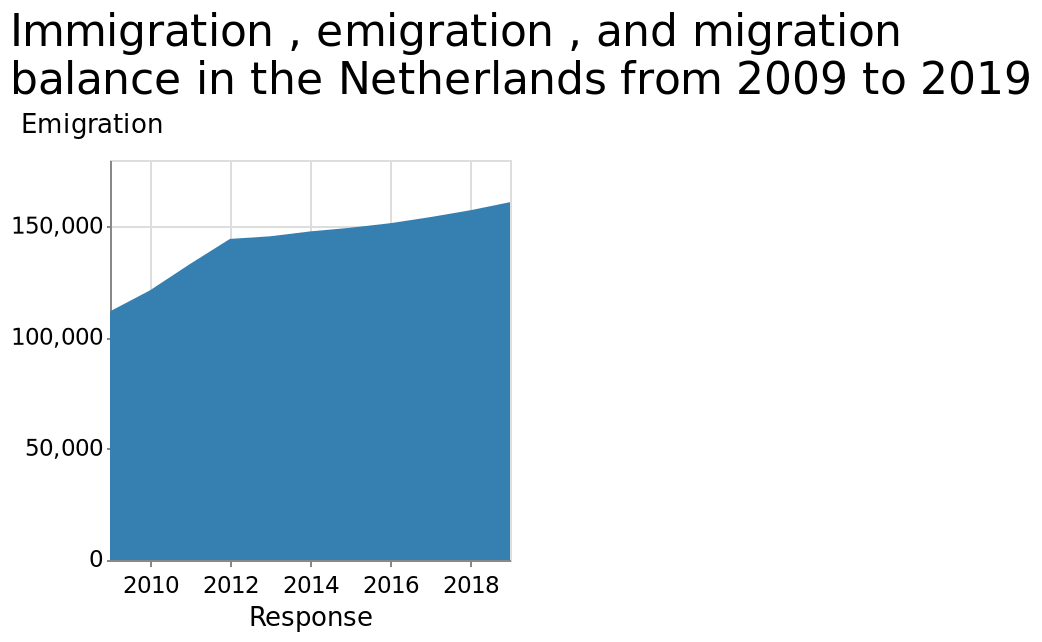<image>
What is the title of the area plot?  The title of the area plot is "Immigration, Emigration, and Migration Balance in the Netherlands from 2009 to 2019". What is measured on the x-axis of the area plot?  The x-axis of the area plot represents the response variable. What was the total balance between immigration, emigration, and migration in 2010? The total balance between immigration, emigration, and migration was just over 100,000 in 2010. please describe the details of the chart Here a is a area plot called Immigration , emigration , and migration balance in the Netherlands from 2009 to 2019. A linear scale from 0 to 150,000 can be seen on the y-axis, marked Emigration. Response is measured on the x-axis. What was the balance between immigration, emigration, and migration in 2018?  The balance between immigration, emigration, and migration was just over 150,000 in 2018. What was the percentage increase in the balance between immigration, emigration, and migration from 2010 to 2012?  The balance between immigration, emigration, and migration increased by approximately 50% from just over 100,000 in 2010 to just under 150,000 in 2012. 